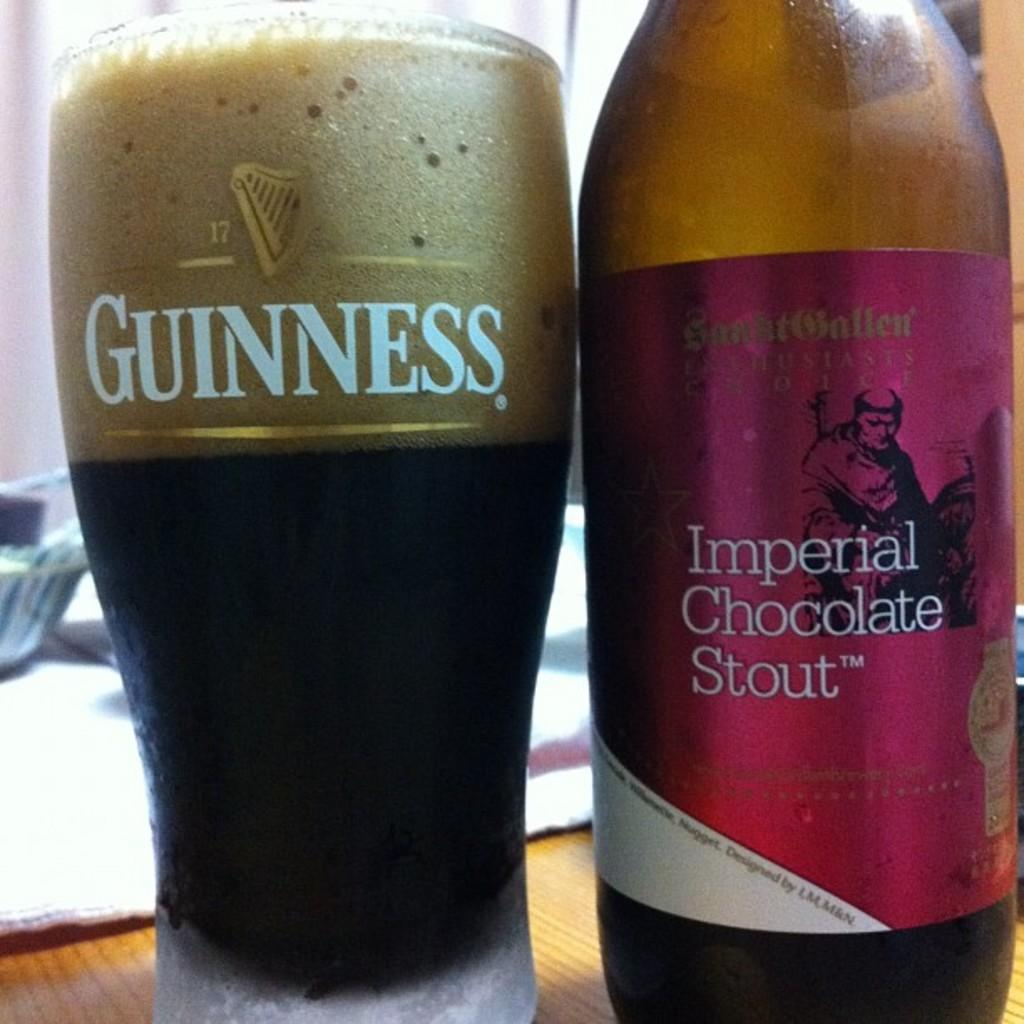<image>
Offer a succinct explanation of the picture presented. A glass of Guinness beer is sitting next to Imperial Chocolate stout bottle. 